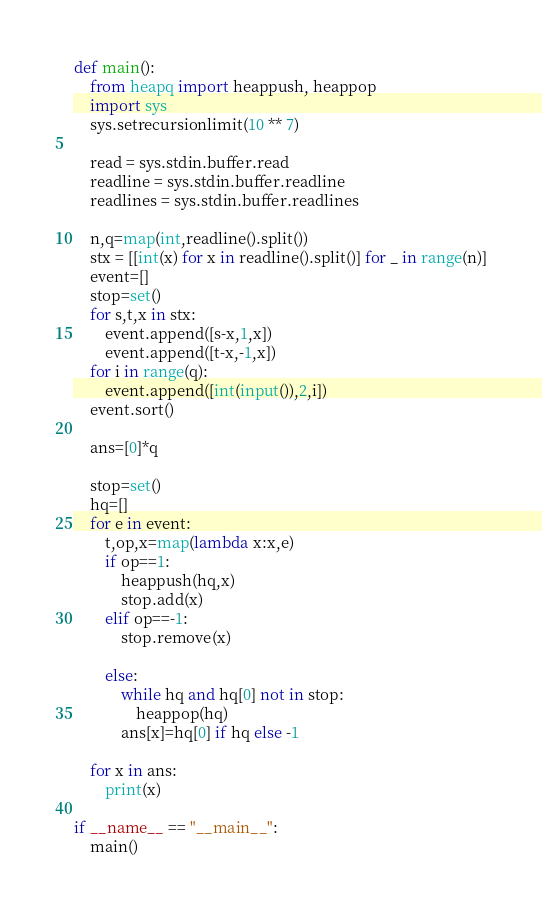Convert code to text. <code><loc_0><loc_0><loc_500><loc_500><_Python_>def main():
    from heapq import heappush, heappop
    import sys
    sys.setrecursionlimit(10 ** 7)
    
    read = sys.stdin.buffer.read
    readline = sys.stdin.buffer.readline
    readlines = sys.stdin.buffer.readlines

    n,q=map(int,readline().split())
    stx = [[int(x) for x in readline().split()] for _ in range(n)]
    event=[]
    stop=set()
    for s,t,x in stx:
        event.append([s-x,1,x])
        event.append([t-x,-1,x])
    for i in range(q):
        event.append([int(input()),2,i])
    event.sort()
    
    ans=[0]*q
    
    stop=set()
    hq=[]
    for e in event:
        t,op,x=map(lambda x:x,e)
        if op==1:
            heappush(hq,x)
            stop.add(x)
        elif op==-1:
            stop.remove(x)
    
        else:
            while hq and hq[0] not in stop:
                heappop(hq) 
            ans[x]=hq[0] if hq else -1
        
    for x in ans:
        print(x)

if __name__ == "__main__":
    main()</code> 